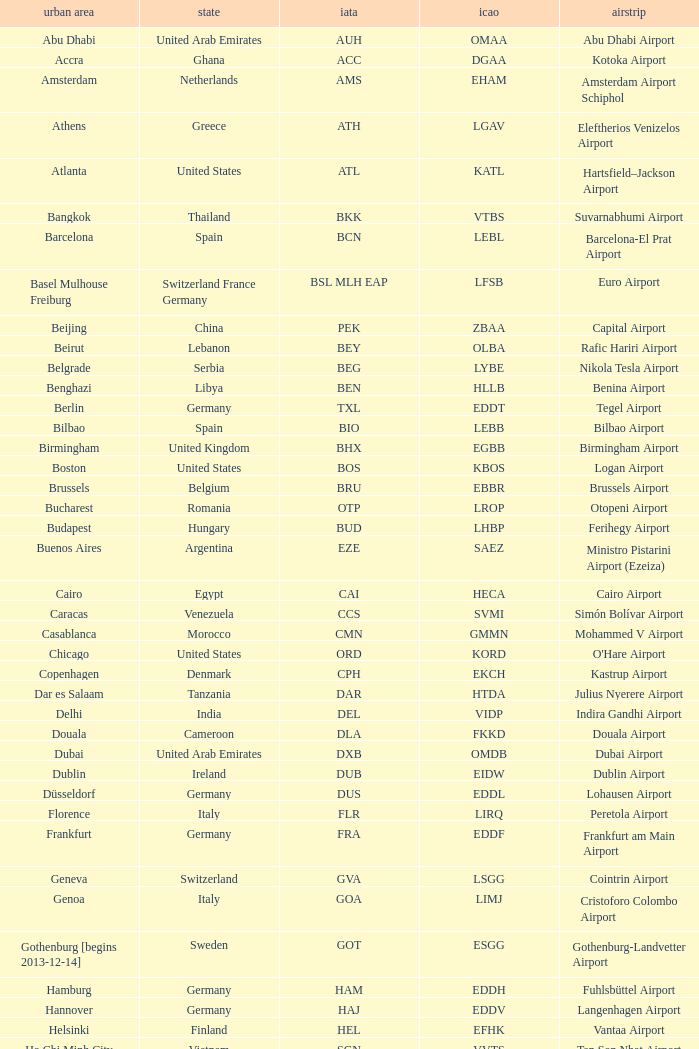What is the IATA of galeão airport? GIG. 